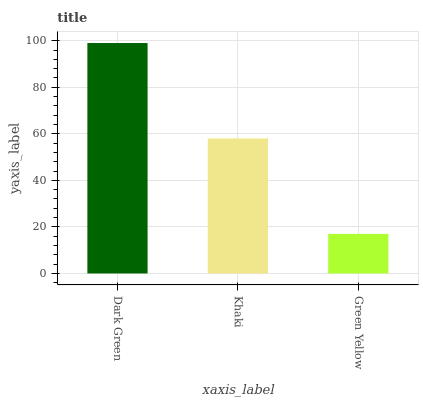Is Green Yellow the minimum?
Answer yes or no. Yes. Is Dark Green the maximum?
Answer yes or no. Yes. Is Khaki the minimum?
Answer yes or no. No. Is Khaki the maximum?
Answer yes or no. No. Is Dark Green greater than Khaki?
Answer yes or no. Yes. Is Khaki less than Dark Green?
Answer yes or no. Yes. Is Khaki greater than Dark Green?
Answer yes or no. No. Is Dark Green less than Khaki?
Answer yes or no. No. Is Khaki the high median?
Answer yes or no. Yes. Is Khaki the low median?
Answer yes or no. Yes. Is Green Yellow the high median?
Answer yes or no. No. Is Dark Green the low median?
Answer yes or no. No. 